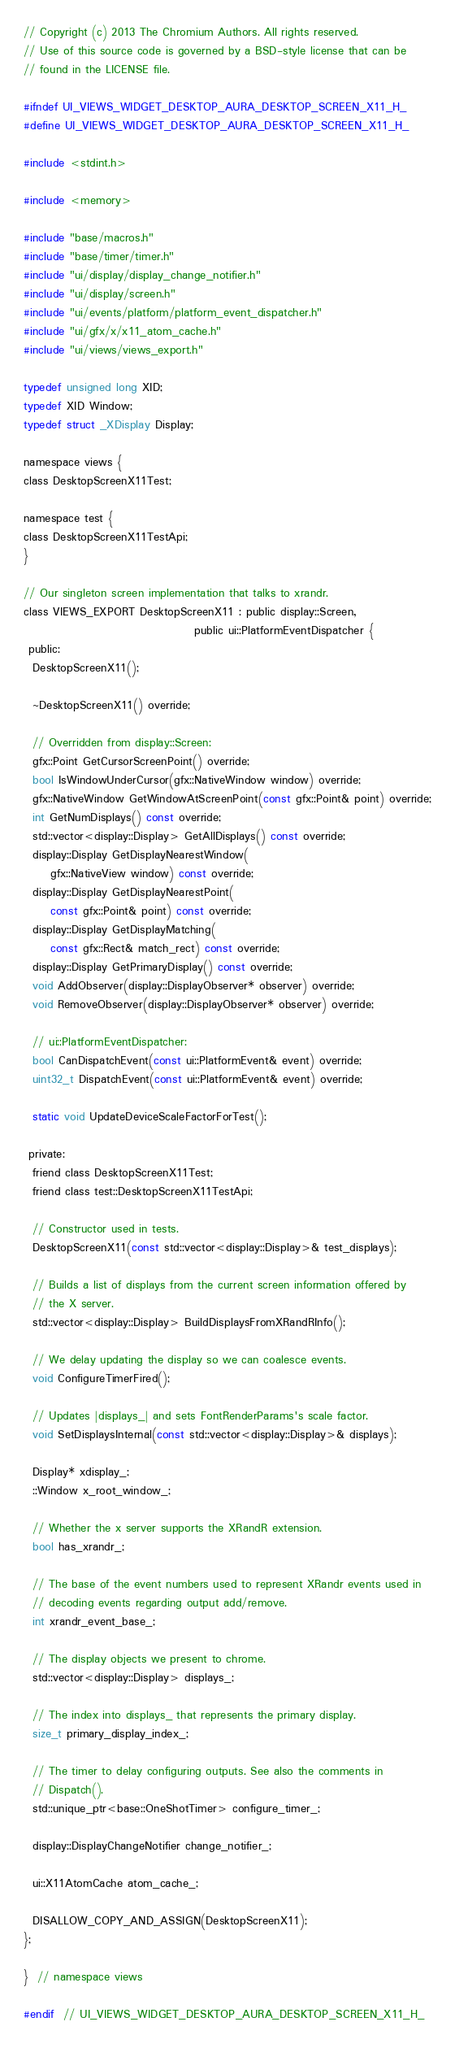Convert code to text. <code><loc_0><loc_0><loc_500><loc_500><_C_>// Copyright (c) 2013 The Chromium Authors. All rights reserved.
// Use of this source code is governed by a BSD-style license that can be
// found in the LICENSE file.

#ifndef UI_VIEWS_WIDGET_DESKTOP_AURA_DESKTOP_SCREEN_X11_H_
#define UI_VIEWS_WIDGET_DESKTOP_AURA_DESKTOP_SCREEN_X11_H_

#include <stdint.h>

#include <memory>

#include "base/macros.h"
#include "base/timer/timer.h"
#include "ui/display/display_change_notifier.h"
#include "ui/display/screen.h"
#include "ui/events/platform/platform_event_dispatcher.h"
#include "ui/gfx/x/x11_atom_cache.h"
#include "ui/views/views_export.h"

typedef unsigned long XID;
typedef XID Window;
typedef struct _XDisplay Display;

namespace views {
class DesktopScreenX11Test;

namespace test {
class DesktopScreenX11TestApi;
}

// Our singleton screen implementation that talks to xrandr.
class VIEWS_EXPORT DesktopScreenX11 : public display::Screen,
                                      public ui::PlatformEventDispatcher {
 public:
  DesktopScreenX11();

  ~DesktopScreenX11() override;

  // Overridden from display::Screen:
  gfx::Point GetCursorScreenPoint() override;
  bool IsWindowUnderCursor(gfx::NativeWindow window) override;
  gfx::NativeWindow GetWindowAtScreenPoint(const gfx::Point& point) override;
  int GetNumDisplays() const override;
  std::vector<display::Display> GetAllDisplays() const override;
  display::Display GetDisplayNearestWindow(
      gfx::NativeView window) const override;
  display::Display GetDisplayNearestPoint(
      const gfx::Point& point) const override;
  display::Display GetDisplayMatching(
      const gfx::Rect& match_rect) const override;
  display::Display GetPrimaryDisplay() const override;
  void AddObserver(display::DisplayObserver* observer) override;
  void RemoveObserver(display::DisplayObserver* observer) override;

  // ui::PlatformEventDispatcher:
  bool CanDispatchEvent(const ui::PlatformEvent& event) override;
  uint32_t DispatchEvent(const ui::PlatformEvent& event) override;

  static void UpdateDeviceScaleFactorForTest();

 private:
  friend class DesktopScreenX11Test;
  friend class test::DesktopScreenX11TestApi;

  // Constructor used in tests.
  DesktopScreenX11(const std::vector<display::Display>& test_displays);

  // Builds a list of displays from the current screen information offered by
  // the X server.
  std::vector<display::Display> BuildDisplaysFromXRandRInfo();

  // We delay updating the display so we can coalesce events.
  void ConfigureTimerFired();

  // Updates |displays_| and sets FontRenderParams's scale factor.
  void SetDisplaysInternal(const std::vector<display::Display>& displays);

  Display* xdisplay_;
  ::Window x_root_window_;

  // Whether the x server supports the XRandR extension.
  bool has_xrandr_;

  // The base of the event numbers used to represent XRandr events used in
  // decoding events regarding output add/remove.
  int xrandr_event_base_;

  // The display objects we present to chrome.
  std::vector<display::Display> displays_;

  // The index into displays_ that represents the primary display.
  size_t primary_display_index_;

  // The timer to delay configuring outputs. See also the comments in
  // Dispatch().
  std::unique_ptr<base::OneShotTimer> configure_timer_;

  display::DisplayChangeNotifier change_notifier_;

  ui::X11AtomCache atom_cache_;

  DISALLOW_COPY_AND_ASSIGN(DesktopScreenX11);
};

}  // namespace views

#endif  // UI_VIEWS_WIDGET_DESKTOP_AURA_DESKTOP_SCREEN_X11_H_
</code> 